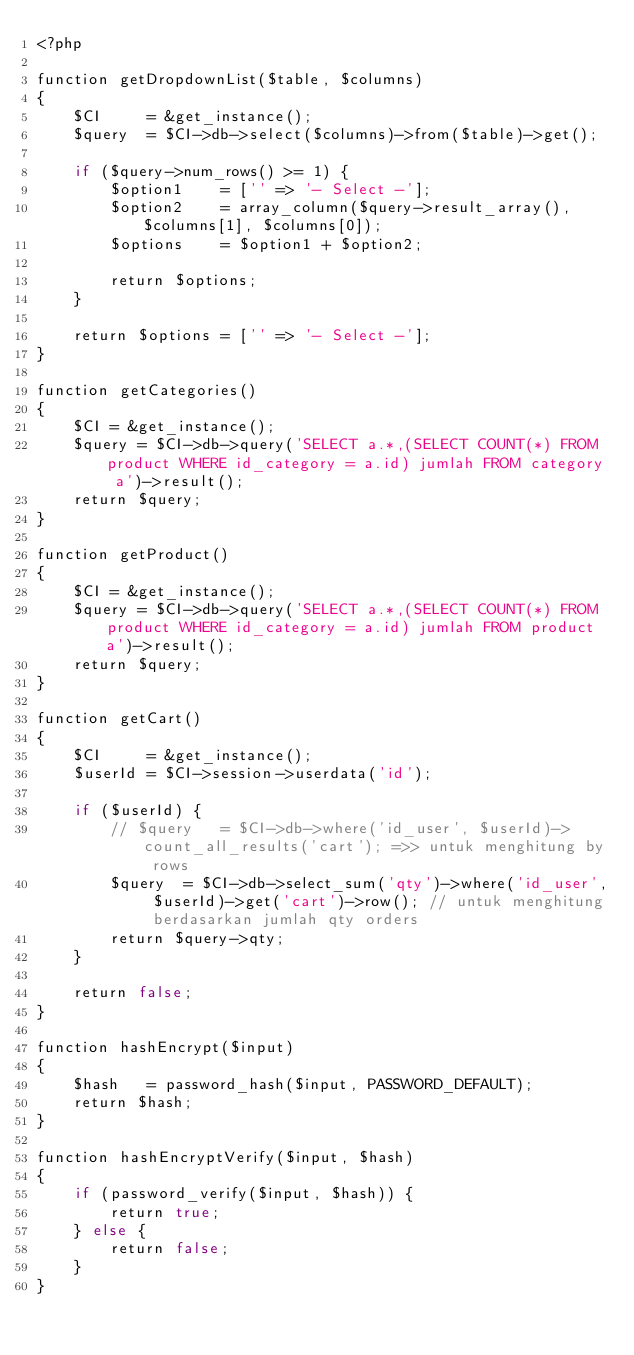<code> <loc_0><loc_0><loc_500><loc_500><_PHP_><?php

function getDropdownList($table, $columns)
{
	$CI		= &get_instance();
	$query	= $CI->db->select($columns)->from($table)->get();

	if ($query->num_rows() >= 1) {
		$option1	= ['' => '- Select -'];
		$option2	= array_column($query->result_array(), $columns[1], $columns[0]);
		$options	= $option1 + $option2;

		return $options;
	}

	return $options	= ['' => '- Select -'];
}

function getCategories()
{
	$CI = &get_instance();
	$query = $CI->db->query('SELECT a.*,(SELECT COUNT(*) FROM product WHERE id_category = a.id) jumlah FROM category a')->result();
	return $query;
}

function getProduct()
{
	$CI = &get_instance();
	$query = $CI->db->query('SELECT a.*,(SELECT COUNT(*) FROM product WHERE id_category = a.id) jumlah FROM product a')->result();
	return $query;
}

function getCart()
{
	$CI		= &get_instance();
	$userId	= $CI->session->userdata('id');

	if ($userId) {
		// $query	= $CI->db->where('id_user', $userId)->count_all_results('cart'); =>> untuk menghitung by rows
		$query	= $CI->db->select_sum('qty')->where('id_user', $userId)->get('cart')->row(); // untuk menghitung berdasarkan jumlah qty orders
		return $query->qty;
	}

	return false;
}

function hashEncrypt($input)
{
	$hash	= password_hash($input, PASSWORD_DEFAULT);
	return $hash;
}

function hashEncryptVerify($input, $hash)
{
	if (password_verify($input, $hash)) {
		return true;
	} else {
		return false;
	}
}
</code> 